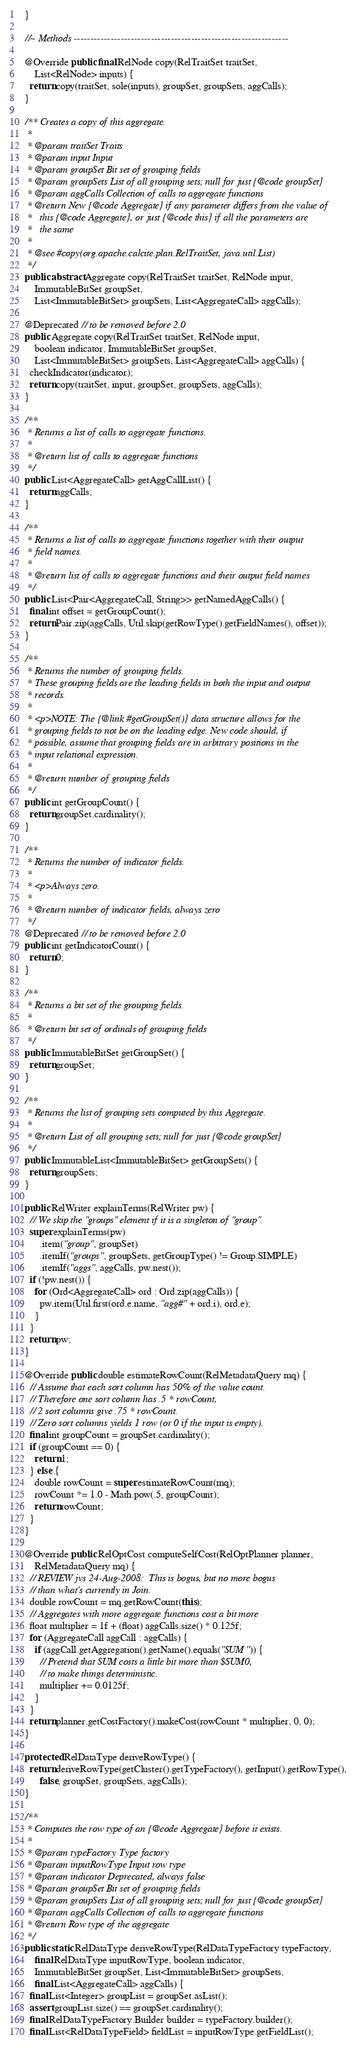Convert code to text. <code><loc_0><loc_0><loc_500><loc_500><_Java_>  }

  //~ Methods ----------------------------------------------------------------

  @Override public final RelNode copy(RelTraitSet traitSet,
      List<RelNode> inputs) {
    return copy(traitSet, sole(inputs), groupSet, groupSets, aggCalls);
  }

  /** Creates a copy of this aggregate.
   *
   * @param traitSet Traits
   * @param input Input
   * @param groupSet Bit set of grouping fields
   * @param groupSets List of all grouping sets; null for just {@code groupSet}
   * @param aggCalls Collection of calls to aggregate functions
   * @return New {@code Aggregate} if any parameter differs from the value of
   *   this {@code Aggregate}, or just {@code this} if all the parameters are
   *   the same
   *
   * @see #copy(org.apache.calcite.plan.RelTraitSet, java.util.List)
   */
  public abstract Aggregate copy(RelTraitSet traitSet, RelNode input,
      ImmutableBitSet groupSet,
      List<ImmutableBitSet> groupSets, List<AggregateCall> aggCalls);

  @Deprecated // to be removed before 2.0
  public Aggregate copy(RelTraitSet traitSet, RelNode input,
      boolean indicator, ImmutableBitSet groupSet,
      List<ImmutableBitSet> groupSets, List<AggregateCall> aggCalls) {
    checkIndicator(indicator);
    return copy(traitSet, input, groupSet, groupSets, aggCalls);
  }

  /**
   * Returns a list of calls to aggregate functions.
   *
   * @return list of calls to aggregate functions
   */
  public List<AggregateCall> getAggCallList() {
    return aggCalls;
  }

  /**
   * Returns a list of calls to aggregate functions together with their output
   * field names.
   *
   * @return list of calls to aggregate functions and their output field names
   */
  public List<Pair<AggregateCall, String>> getNamedAggCalls() {
    final int offset = getGroupCount();
    return Pair.zip(aggCalls, Util.skip(getRowType().getFieldNames(), offset));
  }

  /**
   * Returns the number of grouping fields.
   * These grouping fields are the leading fields in both the input and output
   * records.
   *
   * <p>NOTE: The {@link #getGroupSet()} data structure allows for the
   * grouping fields to not be on the leading edge. New code should, if
   * possible, assume that grouping fields are in arbitrary positions in the
   * input relational expression.
   *
   * @return number of grouping fields
   */
  public int getGroupCount() {
    return groupSet.cardinality();
  }

  /**
   * Returns the number of indicator fields.
   *
   * <p>Always zero.
   *
   * @return number of indicator fields, always zero
   */
  @Deprecated // to be removed before 2.0
  public int getIndicatorCount() {
    return 0;
  }

  /**
   * Returns a bit set of the grouping fields.
   *
   * @return bit set of ordinals of grouping fields
   */
  public ImmutableBitSet getGroupSet() {
    return groupSet;
  }

  /**
   * Returns the list of grouping sets computed by this Aggregate.
   *
   * @return List of all grouping sets; null for just {@code groupSet}
   */
  public ImmutableList<ImmutableBitSet> getGroupSets() {
    return groupSets;
  }

  public RelWriter explainTerms(RelWriter pw) {
    // We skip the "groups" element if it is a singleton of "group".
    super.explainTerms(pw)
        .item("group", groupSet)
        .itemIf("groups", groupSets, getGroupType() != Group.SIMPLE)
        .itemIf("aggs", aggCalls, pw.nest());
    if (!pw.nest()) {
      for (Ord<AggregateCall> ord : Ord.zip(aggCalls)) {
        pw.item(Util.first(ord.e.name, "agg#" + ord.i), ord.e);
      }
    }
    return pw;
  }

  @Override public double estimateRowCount(RelMetadataQuery mq) {
    // Assume that each sort column has 50% of the value count.
    // Therefore one sort column has .5 * rowCount,
    // 2 sort columns give .75 * rowCount.
    // Zero sort columns yields 1 row (or 0 if the input is empty).
    final int groupCount = groupSet.cardinality();
    if (groupCount == 0) {
      return 1;
    } else {
      double rowCount = super.estimateRowCount(mq);
      rowCount *= 1.0 - Math.pow(.5, groupCount);
      return rowCount;
    }
  }

  @Override public RelOptCost computeSelfCost(RelOptPlanner planner,
      RelMetadataQuery mq) {
    // REVIEW jvs 24-Aug-2008:  This is bogus, but no more bogus
    // than what's currently in Join.
    double rowCount = mq.getRowCount(this);
    // Aggregates with more aggregate functions cost a bit more
    float multiplier = 1f + (float) aggCalls.size() * 0.125f;
    for (AggregateCall aggCall : aggCalls) {
      if (aggCall.getAggregation().getName().equals("SUM")) {
        // Pretend that SUM costs a little bit more than $SUM0,
        // to make things deterministic.
        multiplier += 0.0125f;
      }
    }
    return planner.getCostFactory().makeCost(rowCount * multiplier, 0, 0);
  }

  protected RelDataType deriveRowType() {
    return deriveRowType(getCluster().getTypeFactory(), getInput().getRowType(),
        false, groupSet, groupSets, aggCalls);
  }

  /**
   * Computes the row type of an {@code Aggregate} before it exists.
   *
   * @param typeFactory Type factory
   * @param inputRowType Input row type
   * @param indicator Deprecated, always false
   * @param groupSet Bit set of grouping fields
   * @param groupSets List of all grouping sets; null for just {@code groupSet}
   * @param aggCalls Collection of calls to aggregate functions
   * @return Row type of the aggregate
   */
  public static RelDataType deriveRowType(RelDataTypeFactory typeFactory,
      final RelDataType inputRowType, boolean indicator,
      ImmutableBitSet groupSet, List<ImmutableBitSet> groupSets,
      final List<AggregateCall> aggCalls) {
    final List<Integer> groupList = groupSet.asList();
    assert groupList.size() == groupSet.cardinality();
    final RelDataTypeFactory.Builder builder = typeFactory.builder();
    final List<RelDataTypeField> fieldList = inputRowType.getFieldList();</code> 